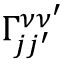<formula> <loc_0><loc_0><loc_500><loc_500>\Gamma _ { j j ^ { \prime } } ^ { \nu \nu ^ { \prime } }</formula> 